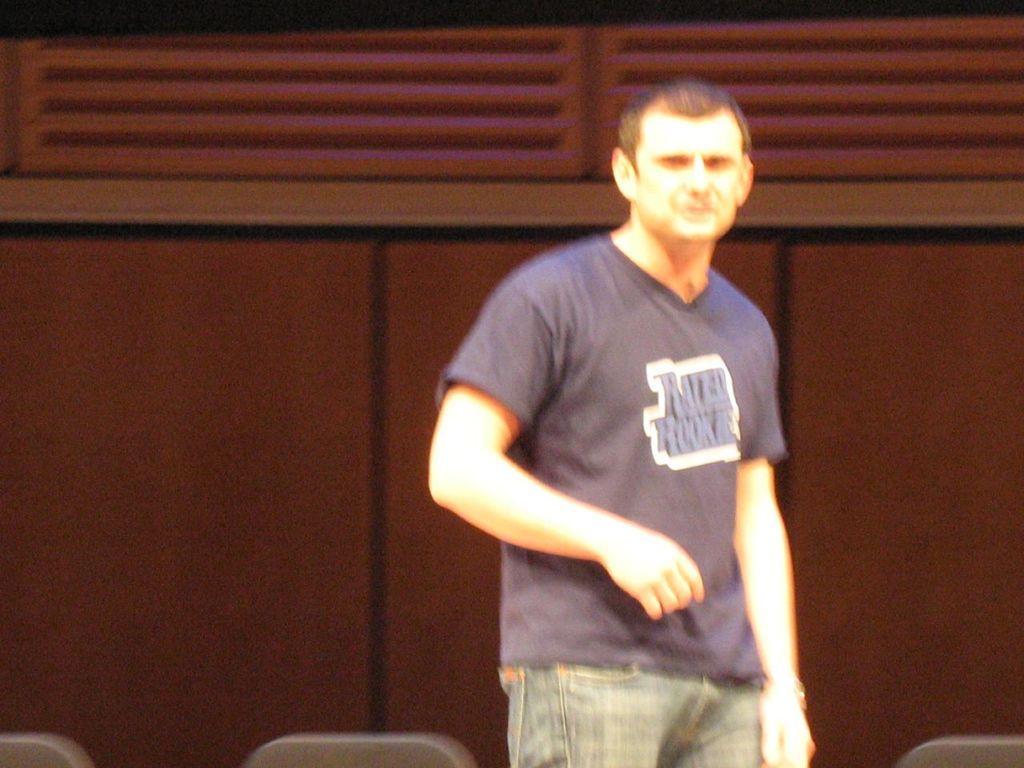How would you summarize this image in a sentence or two? In the image I can see one person is standing. The given image is on blurred. 